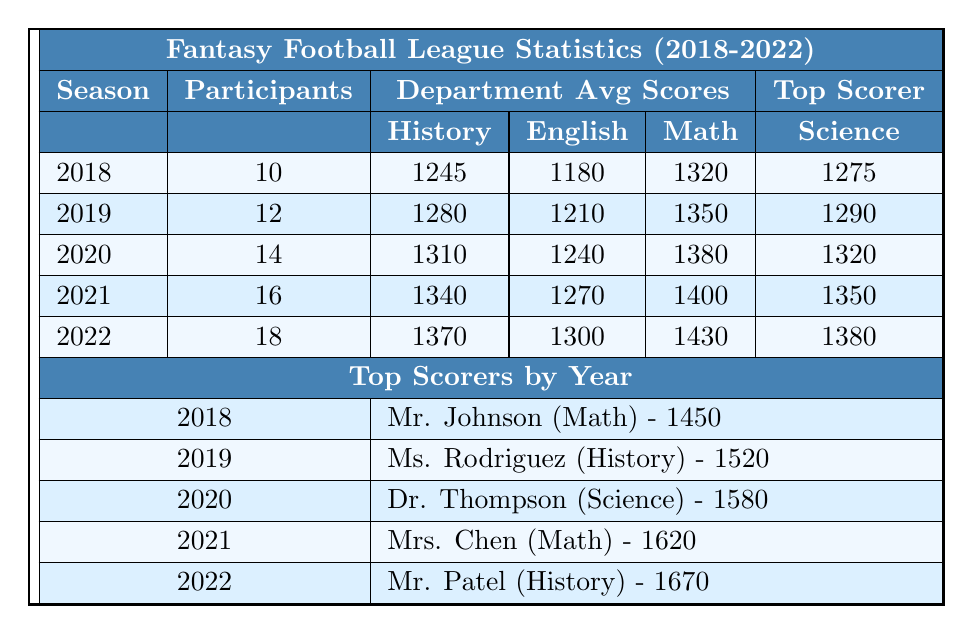What was the average score of the Math department in 2019? In 2019, the average score for the Math department is listed directly in the table as 1350.
Answer: 1350 How many participants were there in total in the 2020 season? The total number of participants is explicitly shown in the table for the 2020 season, which is 14.
Answer: 14 Which department had the highest average score in 2021? In 2021, the average scores for each department are 1340 (History), 1270 (English), 1400 (Math), and 1350 (Science). The Math department had the highest average score of 1400.
Answer: Math Who was the top scorer for the History department in 2022? The top scorer for the 2022 season from the History department is listed in the table as Mr. Patel, with a score of 1670.
Answer: Mr. Patel What is the difference between the top scorer's scores in 2021 and 2020? The top scorer in 2021 scored 1620 (Mrs. Chen) and in 2020 scored 1580 (Dr. Thompson). The difference is 1620 - 1580 = 40.
Answer: 40 Based on the data, did the number of participants increase every year from 2018 to 2022? The number of participants each year is 10 (2018), 12 (2019), 14 (2020), 16 (2021), and 18 (2022), indicating an increase every year.
Answer: Yes Which department consistently scored the highest average score from 2018 to 2022? By comparing the average scores, Math had scores of 1320 (2018), 1350 (2019), 1380 (2020), 1400 (2021), and 1430 (2022), indicating it was the highest in all years.
Answer: Math What is the average score for the Science department across all five seasons? The average scores for Science are 1275 (2018), 1290 (2019), 1320 (2020), 1350 (2021), and 1380 (2022). To find the average: (1275 + 1290 + 1320 + 1350 + 1380) / 5 = 1323.
Answer: 1323 Was Ms. Rodriguez the top scorer for any season? Checking the table, she was the top scorer in 2019 with a score of 1520.
Answer: Yes How many total participants were there in the Fantasy Football League across all seasons combined? The total participants per season are 10 (2018), 12 (2019), 14 (2020), 16 (2021), and 18 (2022). Summing these gives 10 + 12 + 14 + 16 + 18 = 70.
Answer: 70 